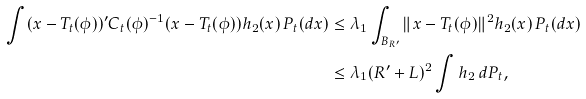Convert formula to latex. <formula><loc_0><loc_0><loc_500><loc_500>\int ( x - T _ { t } ( \phi ) ) ^ { \prime } C _ { t } ( \phi ) ^ { - 1 } ( x - T _ { t } ( \phi ) ) h _ { 2 } ( x ) \, P _ { t } ( d x ) & \leq \lambda _ { 1 } \int _ { B _ { R ^ { \prime } } } \| x - T _ { t } ( \phi ) \| ^ { 2 } h _ { 2 } ( x ) \, P _ { t } ( d x ) \\ & \leq \lambda _ { 1 } ( R ^ { \prime } + L ) ^ { 2 } \int h _ { 2 } \, d P _ { t } ,</formula> 